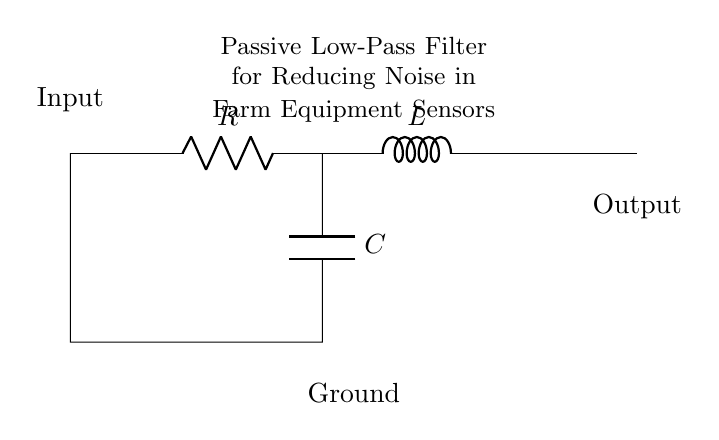what are the components in this circuit? The circuit consists of a resistor, an inductor, and a capacitor. These components are vital for filtering purposes in the circuit.
Answer: resistor, inductor, capacitor what is the purpose of this circuit? The purpose of this circuit is to act as a passive low-pass filter to reduce noise from farm equipment sensors. This functionality allows only lower frequency signals to pass while attenuating higher frequencies.
Answer: reduce noise what is the input to this circuit? The input is represented at the left side of the circuit diagram and is where the signal enters the filter. It is connected to the resistor, indicating the starting point for filtering.
Answer: Input what type of filter is represented in this circuit? The circuit is a passive low-pass filter as indicated by the arrangement of the components which allows low-frequency signals to pass while blocking higher frequencies.
Answer: passive low-pass filter how does the output connect in this circuit? The output connects to the right side of the circuit diagram after the inductor, allowing the filtered signal to exit the circuit for further use in the system.
Answer: Output what is the effect of increasing the resistance in this circuit? Increasing the resistance will lower the cutoff frequency of the filter, meaning less high-frequency noise will pass through, thereby improving filtering efficiency at lower frequencies.
Answer: lower cutoff frequency what happens if the capacitor is removed from this circuit? If the capacitor is removed, the circuit will no longer function effectively as a low-pass filter, allowing high-frequency noise to pass through, which can interfere with sensor operation.
Answer: no filtering 